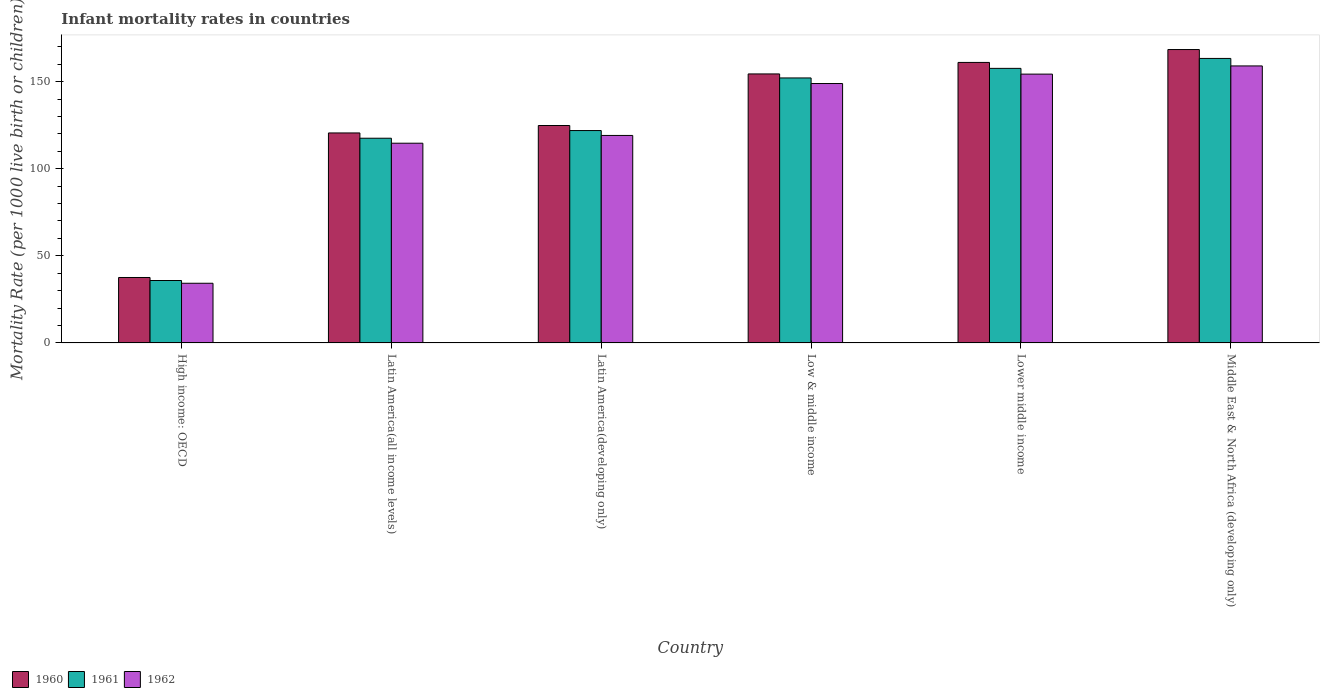How many different coloured bars are there?
Provide a succinct answer. 3. How many groups of bars are there?
Give a very brief answer. 6. How many bars are there on the 2nd tick from the left?
Your answer should be compact. 3. How many bars are there on the 6th tick from the right?
Keep it short and to the point. 3. What is the label of the 3rd group of bars from the left?
Give a very brief answer. Latin America(developing only). What is the infant mortality rate in 1961 in Low & middle income?
Provide a succinct answer. 152.1. Across all countries, what is the maximum infant mortality rate in 1962?
Give a very brief answer. 159. Across all countries, what is the minimum infant mortality rate in 1961?
Ensure brevity in your answer.  35.84. In which country was the infant mortality rate in 1962 maximum?
Provide a short and direct response. Middle East & North Africa (developing only). In which country was the infant mortality rate in 1961 minimum?
Provide a short and direct response. High income: OECD. What is the total infant mortality rate in 1961 in the graph?
Give a very brief answer. 748.24. What is the difference between the infant mortality rate in 1960 in Low & middle income and that in Lower middle income?
Your answer should be compact. -6.6. What is the difference between the infant mortality rate in 1960 in High income: OECD and the infant mortality rate in 1961 in Latin America(developing only)?
Make the answer very short. -84.33. What is the average infant mortality rate in 1960 per country?
Make the answer very short. 127.78. What is the difference between the infant mortality rate of/in 1960 and infant mortality rate of/in 1961 in Middle East & North Africa (developing only)?
Offer a terse response. 5.1. What is the ratio of the infant mortality rate in 1962 in Latin America(developing only) to that in Lower middle income?
Make the answer very short. 0.77. What is the difference between the highest and the second highest infant mortality rate in 1960?
Provide a succinct answer. 7.4. What is the difference between the highest and the lowest infant mortality rate in 1961?
Offer a terse response. 127.46. Is the sum of the infant mortality rate in 1961 in High income: OECD and Lower middle income greater than the maximum infant mortality rate in 1960 across all countries?
Make the answer very short. Yes. Is it the case that in every country, the sum of the infant mortality rate in 1961 and infant mortality rate in 1962 is greater than the infant mortality rate in 1960?
Your answer should be compact. Yes. How many bars are there?
Provide a succinct answer. 18. Are all the bars in the graph horizontal?
Your answer should be compact. No. How many countries are there in the graph?
Provide a short and direct response. 6. Where does the legend appear in the graph?
Make the answer very short. Bottom left. How many legend labels are there?
Keep it short and to the point. 3. What is the title of the graph?
Offer a terse response. Infant mortality rates in countries. What is the label or title of the Y-axis?
Offer a terse response. Mortality Rate (per 1000 live birth or children). What is the Mortality Rate (per 1000 live birth or children) of 1960 in High income: OECD?
Provide a short and direct response. 37.57. What is the Mortality Rate (per 1000 live birth or children) in 1961 in High income: OECD?
Offer a very short reply. 35.84. What is the Mortality Rate (per 1000 live birth or children) of 1962 in High income: OECD?
Provide a short and direct response. 34.26. What is the Mortality Rate (per 1000 live birth or children) in 1960 in Latin America(all income levels)?
Your response must be concise. 120.53. What is the Mortality Rate (per 1000 live birth or children) in 1961 in Latin America(all income levels)?
Give a very brief answer. 117.5. What is the Mortality Rate (per 1000 live birth or children) of 1962 in Latin America(all income levels)?
Your answer should be compact. 114.64. What is the Mortality Rate (per 1000 live birth or children) in 1960 in Latin America(developing only)?
Make the answer very short. 124.8. What is the Mortality Rate (per 1000 live birth or children) in 1961 in Latin America(developing only)?
Offer a terse response. 121.9. What is the Mortality Rate (per 1000 live birth or children) of 1962 in Latin America(developing only)?
Offer a terse response. 119.1. What is the Mortality Rate (per 1000 live birth or children) of 1960 in Low & middle income?
Provide a short and direct response. 154.4. What is the Mortality Rate (per 1000 live birth or children) of 1961 in Low & middle income?
Provide a succinct answer. 152.1. What is the Mortality Rate (per 1000 live birth or children) in 1962 in Low & middle income?
Your response must be concise. 148.9. What is the Mortality Rate (per 1000 live birth or children) of 1960 in Lower middle income?
Provide a succinct answer. 161. What is the Mortality Rate (per 1000 live birth or children) in 1961 in Lower middle income?
Your answer should be very brief. 157.6. What is the Mortality Rate (per 1000 live birth or children) of 1962 in Lower middle income?
Your answer should be very brief. 154.3. What is the Mortality Rate (per 1000 live birth or children) of 1960 in Middle East & North Africa (developing only)?
Give a very brief answer. 168.4. What is the Mortality Rate (per 1000 live birth or children) of 1961 in Middle East & North Africa (developing only)?
Provide a succinct answer. 163.3. What is the Mortality Rate (per 1000 live birth or children) in 1962 in Middle East & North Africa (developing only)?
Offer a very short reply. 159. Across all countries, what is the maximum Mortality Rate (per 1000 live birth or children) of 1960?
Provide a succinct answer. 168.4. Across all countries, what is the maximum Mortality Rate (per 1000 live birth or children) in 1961?
Offer a terse response. 163.3. Across all countries, what is the maximum Mortality Rate (per 1000 live birth or children) of 1962?
Offer a terse response. 159. Across all countries, what is the minimum Mortality Rate (per 1000 live birth or children) in 1960?
Your answer should be very brief. 37.57. Across all countries, what is the minimum Mortality Rate (per 1000 live birth or children) in 1961?
Provide a short and direct response. 35.84. Across all countries, what is the minimum Mortality Rate (per 1000 live birth or children) of 1962?
Give a very brief answer. 34.26. What is the total Mortality Rate (per 1000 live birth or children) of 1960 in the graph?
Make the answer very short. 766.7. What is the total Mortality Rate (per 1000 live birth or children) of 1961 in the graph?
Offer a terse response. 748.24. What is the total Mortality Rate (per 1000 live birth or children) in 1962 in the graph?
Your answer should be very brief. 730.19. What is the difference between the Mortality Rate (per 1000 live birth or children) of 1960 in High income: OECD and that in Latin America(all income levels)?
Make the answer very short. -82.96. What is the difference between the Mortality Rate (per 1000 live birth or children) of 1961 in High income: OECD and that in Latin America(all income levels)?
Provide a short and direct response. -81.67. What is the difference between the Mortality Rate (per 1000 live birth or children) of 1962 in High income: OECD and that in Latin America(all income levels)?
Give a very brief answer. -80.38. What is the difference between the Mortality Rate (per 1000 live birth or children) of 1960 in High income: OECD and that in Latin America(developing only)?
Your answer should be very brief. -87.23. What is the difference between the Mortality Rate (per 1000 live birth or children) in 1961 in High income: OECD and that in Latin America(developing only)?
Give a very brief answer. -86.06. What is the difference between the Mortality Rate (per 1000 live birth or children) in 1962 in High income: OECD and that in Latin America(developing only)?
Provide a succinct answer. -84.84. What is the difference between the Mortality Rate (per 1000 live birth or children) of 1960 in High income: OECD and that in Low & middle income?
Provide a short and direct response. -116.83. What is the difference between the Mortality Rate (per 1000 live birth or children) of 1961 in High income: OECD and that in Low & middle income?
Make the answer very short. -116.26. What is the difference between the Mortality Rate (per 1000 live birth or children) of 1962 in High income: OECD and that in Low & middle income?
Offer a terse response. -114.64. What is the difference between the Mortality Rate (per 1000 live birth or children) of 1960 in High income: OECD and that in Lower middle income?
Give a very brief answer. -123.43. What is the difference between the Mortality Rate (per 1000 live birth or children) of 1961 in High income: OECD and that in Lower middle income?
Provide a short and direct response. -121.76. What is the difference between the Mortality Rate (per 1000 live birth or children) in 1962 in High income: OECD and that in Lower middle income?
Your answer should be very brief. -120.04. What is the difference between the Mortality Rate (per 1000 live birth or children) of 1960 in High income: OECD and that in Middle East & North Africa (developing only)?
Make the answer very short. -130.83. What is the difference between the Mortality Rate (per 1000 live birth or children) of 1961 in High income: OECD and that in Middle East & North Africa (developing only)?
Offer a terse response. -127.46. What is the difference between the Mortality Rate (per 1000 live birth or children) of 1962 in High income: OECD and that in Middle East & North Africa (developing only)?
Offer a terse response. -124.74. What is the difference between the Mortality Rate (per 1000 live birth or children) of 1960 in Latin America(all income levels) and that in Latin America(developing only)?
Offer a terse response. -4.27. What is the difference between the Mortality Rate (per 1000 live birth or children) in 1961 in Latin America(all income levels) and that in Latin America(developing only)?
Provide a succinct answer. -4.4. What is the difference between the Mortality Rate (per 1000 live birth or children) of 1962 in Latin America(all income levels) and that in Latin America(developing only)?
Provide a succinct answer. -4.46. What is the difference between the Mortality Rate (per 1000 live birth or children) of 1960 in Latin America(all income levels) and that in Low & middle income?
Give a very brief answer. -33.87. What is the difference between the Mortality Rate (per 1000 live birth or children) of 1961 in Latin America(all income levels) and that in Low & middle income?
Provide a short and direct response. -34.6. What is the difference between the Mortality Rate (per 1000 live birth or children) in 1962 in Latin America(all income levels) and that in Low & middle income?
Offer a very short reply. -34.26. What is the difference between the Mortality Rate (per 1000 live birth or children) in 1960 in Latin America(all income levels) and that in Lower middle income?
Ensure brevity in your answer.  -40.47. What is the difference between the Mortality Rate (per 1000 live birth or children) of 1961 in Latin America(all income levels) and that in Lower middle income?
Keep it short and to the point. -40.1. What is the difference between the Mortality Rate (per 1000 live birth or children) of 1962 in Latin America(all income levels) and that in Lower middle income?
Offer a terse response. -39.66. What is the difference between the Mortality Rate (per 1000 live birth or children) in 1960 in Latin America(all income levels) and that in Middle East & North Africa (developing only)?
Provide a short and direct response. -47.87. What is the difference between the Mortality Rate (per 1000 live birth or children) in 1961 in Latin America(all income levels) and that in Middle East & North Africa (developing only)?
Make the answer very short. -45.8. What is the difference between the Mortality Rate (per 1000 live birth or children) of 1962 in Latin America(all income levels) and that in Middle East & North Africa (developing only)?
Ensure brevity in your answer.  -44.36. What is the difference between the Mortality Rate (per 1000 live birth or children) of 1960 in Latin America(developing only) and that in Low & middle income?
Offer a very short reply. -29.6. What is the difference between the Mortality Rate (per 1000 live birth or children) of 1961 in Latin America(developing only) and that in Low & middle income?
Offer a very short reply. -30.2. What is the difference between the Mortality Rate (per 1000 live birth or children) in 1962 in Latin America(developing only) and that in Low & middle income?
Make the answer very short. -29.8. What is the difference between the Mortality Rate (per 1000 live birth or children) of 1960 in Latin America(developing only) and that in Lower middle income?
Make the answer very short. -36.2. What is the difference between the Mortality Rate (per 1000 live birth or children) of 1961 in Latin America(developing only) and that in Lower middle income?
Provide a short and direct response. -35.7. What is the difference between the Mortality Rate (per 1000 live birth or children) in 1962 in Latin America(developing only) and that in Lower middle income?
Your answer should be compact. -35.2. What is the difference between the Mortality Rate (per 1000 live birth or children) of 1960 in Latin America(developing only) and that in Middle East & North Africa (developing only)?
Your answer should be compact. -43.6. What is the difference between the Mortality Rate (per 1000 live birth or children) of 1961 in Latin America(developing only) and that in Middle East & North Africa (developing only)?
Make the answer very short. -41.4. What is the difference between the Mortality Rate (per 1000 live birth or children) of 1962 in Latin America(developing only) and that in Middle East & North Africa (developing only)?
Ensure brevity in your answer.  -39.9. What is the difference between the Mortality Rate (per 1000 live birth or children) of 1961 in Low & middle income and that in Lower middle income?
Keep it short and to the point. -5.5. What is the difference between the Mortality Rate (per 1000 live birth or children) in 1960 in Lower middle income and that in Middle East & North Africa (developing only)?
Your answer should be very brief. -7.4. What is the difference between the Mortality Rate (per 1000 live birth or children) of 1961 in Lower middle income and that in Middle East & North Africa (developing only)?
Provide a short and direct response. -5.7. What is the difference between the Mortality Rate (per 1000 live birth or children) in 1962 in Lower middle income and that in Middle East & North Africa (developing only)?
Keep it short and to the point. -4.7. What is the difference between the Mortality Rate (per 1000 live birth or children) in 1960 in High income: OECD and the Mortality Rate (per 1000 live birth or children) in 1961 in Latin America(all income levels)?
Provide a succinct answer. -79.93. What is the difference between the Mortality Rate (per 1000 live birth or children) of 1960 in High income: OECD and the Mortality Rate (per 1000 live birth or children) of 1962 in Latin America(all income levels)?
Your answer should be very brief. -77.07. What is the difference between the Mortality Rate (per 1000 live birth or children) in 1961 in High income: OECD and the Mortality Rate (per 1000 live birth or children) in 1962 in Latin America(all income levels)?
Your answer should be compact. -78.8. What is the difference between the Mortality Rate (per 1000 live birth or children) in 1960 in High income: OECD and the Mortality Rate (per 1000 live birth or children) in 1961 in Latin America(developing only)?
Offer a very short reply. -84.33. What is the difference between the Mortality Rate (per 1000 live birth or children) in 1960 in High income: OECD and the Mortality Rate (per 1000 live birth or children) in 1962 in Latin America(developing only)?
Provide a succinct answer. -81.53. What is the difference between the Mortality Rate (per 1000 live birth or children) in 1961 in High income: OECD and the Mortality Rate (per 1000 live birth or children) in 1962 in Latin America(developing only)?
Your answer should be compact. -83.26. What is the difference between the Mortality Rate (per 1000 live birth or children) of 1960 in High income: OECD and the Mortality Rate (per 1000 live birth or children) of 1961 in Low & middle income?
Make the answer very short. -114.53. What is the difference between the Mortality Rate (per 1000 live birth or children) in 1960 in High income: OECD and the Mortality Rate (per 1000 live birth or children) in 1962 in Low & middle income?
Make the answer very short. -111.33. What is the difference between the Mortality Rate (per 1000 live birth or children) in 1961 in High income: OECD and the Mortality Rate (per 1000 live birth or children) in 1962 in Low & middle income?
Your response must be concise. -113.06. What is the difference between the Mortality Rate (per 1000 live birth or children) in 1960 in High income: OECD and the Mortality Rate (per 1000 live birth or children) in 1961 in Lower middle income?
Offer a terse response. -120.03. What is the difference between the Mortality Rate (per 1000 live birth or children) in 1960 in High income: OECD and the Mortality Rate (per 1000 live birth or children) in 1962 in Lower middle income?
Make the answer very short. -116.73. What is the difference between the Mortality Rate (per 1000 live birth or children) in 1961 in High income: OECD and the Mortality Rate (per 1000 live birth or children) in 1962 in Lower middle income?
Offer a terse response. -118.46. What is the difference between the Mortality Rate (per 1000 live birth or children) of 1960 in High income: OECD and the Mortality Rate (per 1000 live birth or children) of 1961 in Middle East & North Africa (developing only)?
Provide a succinct answer. -125.73. What is the difference between the Mortality Rate (per 1000 live birth or children) of 1960 in High income: OECD and the Mortality Rate (per 1000 live birth or children) of 1962 in Middle East & North Africa (developing only)?
Provide a succinct answer. -121.43. What is the difference between the Mortality Rate (per 1000 live birth or children) in 1961 in High income: OECD and the Mortality Rate (per 1000 live birth or children) in 1962 in Middle East & North Africa (developing only)?
Provide a short and direct response. -123.16. What is the difference between the Mortality Rate (per 1000 live birth or children) in 1960 in Latin America(all income levels) and the Mortality Rate (per 1000 live birth or children) in 1961 in Latin America(developing only)?
Provide a short and direct response. -1.37. What is the difference between the Mortality Rate (per 1000 live birth or children) of 1960 in Latin America(all income levels) and the Mortality Rate (per 1000 live birth or children) of 1962 in Latin America(developing only)?
Your answer should be very brief. 1.43. What is the difference between the Mortality Rate (per 1000 live birth or children) of 1961 in Latin America(all income levels) and the Mortality Rate (per 1000 live birth or children) of 1962 in Latin America(developing only)?
Your answer should be very brief. -1.6. What is the difference between the Mortality Rate (per 1000 live birth or children) of 1960 in Latin America(all income levels) and the Mortality Rate (per 1000 live birth or children) of 1961 in Low & middle income?
Provide a succinct answer. -31.57. What is the difference between the Mortality Rate (per 1000 live birth or children) of 1960 in Latin America(all income levels) and the Mortality Rate (per 1000 live birth or children) of 1962 in Low & middle income?
Your answer should be very brief. -28.37. What is the difference between the Mortality Rate (per 1000 live birth or children) in 1961 in Latin America(all income levels) and the Mortality Rate (per 1000 live birth or children) in 1962 in Low & middle income?
Your answer should be compact. -31.4. What is the difference between the Mortality Rate (per 1000 live birth or children) in 1960 in Latin America(all income levels) and the Mortality Rate (per 1000 live birth or children) in 1961 in Lower middle income?
Your answer should be compact. -37.07. What is the difference between the Mortality Rate (per 1000 live birth or children) of 1960 in Latin America(all income levels) and the Mortality Rate (per 1000 live birth or children) of 1962 in Lower middle income?
Provide a short and direct response. -33.77. What is the difference between the Mortality Rate (per 1000 live birth or children) of 1961 in Latin America(all income levels) and the Mortality Rate (per 1000 live birth or children) of 1962 in Lower middle income?
Provide a succinct answer. -36.8. What is the difference between the Mortality Rate (per 1000 live birth or children) of 1960 in Latin America(all income levels) and the Mortality Rate (per 1000 live birth or children) of 1961 in Middle East & North Africa (developing only)?
Your answer should be compact. -42.77. What is the difference between the Mortality Rate (per 1000 live birth or children) in 1960 in Latin America(all income levels) and the Mortality Rate (per 1000 live birth or children) in 1962 in Middle East & North Africa (developing only)?
Provide a succinct answer. -38.47. What is the difference between the Mortality Rate (per 1000 live birth or children) in 1961 in Latin America(all income levels) and the Mortality Rate (per 1000 live birth or children) in 1962 in Middle East & North Africa (developing only)?
Offer a terse response. -41.5. What is the difference between the Mortality Rate (per 1000 live birth or children) in 1960 in Latin America(developing only) and the Mortality Rate (per 1000 live birth or children) in 1961 in Low & middle income?
Ensure brevity in your answer.  -27.3. What is the difference between the Mortality Rate (per 1000 live birth or children) of 1960 in Latin America(developing only) and the Mortality Rate (per 1000 live birth or children) of 1962 in Low & middle income?
Provide a short and direct response. -24.1. What is the difference between the Mortality Rate (per 1000 live birth or children) of 1960 in Latin America(developing only) and the Mortality Rate (per 1000 live birth or children) of 1961 in Lower middle income?
Your response must be concise. -32.8. What is the difference between the Mortality Rate (per 1000 live birth or children) in 1960 in Latin America(developing only) and the Mortality Rate (per 1000 live birth or children) in 1962 in Lower middle income?
Provide a succinct answer. -29.5. What is the difference between the Mortality Rate (per 1000 live birth or children) of 1961 in Latin America(developing only) and the Mortality Rate (per 1000 live birth or children) of 1962 in Lower middle income?
Give a very brief answer. -32.4. What is the difference between the Mortality Rate (per 1000 live birth or children) in 1960 in Latin America(developing only) and the Mortality Rate (per 1000 live birth or children) in 1961 in Middle East & North Africa (developing only)?
Make the answer very short. -38.5. What is the difference between the Mortality Rate (per 1000 live birth or children) of 1960 in Latin America(developing only) and the Mortality Rate (per 1000 live birth or children) of 1962 in Middle East & North Africa (developing only)?
Your answer should be very brief. -34.2. What is the difference between the Mortality Rate (per 1000 live birth or children) in 1961 in Latin America(developing only) and the Mortality Rate (per 1000 live birth or children) in 1962 in Middle East & North Africa (developing only)?
Provide a short and direct response. -37.1. What is the difference between the Mortality Rate (per 1000 live birth or children) in 1960 in Low & middle income and the Mortality Rate (per 1000 live birth or children) in 1961 in Lower middle income?
Offer a very short reply. -3.2. What is the average Mortality Rate (per 1000 live birth or children) in 1960 per country?
Your answer should be compact. 127.78. What is the average Mortality Rate (per 1000 live birth or children) in 1961 per country?
Provide a short and direct response. 124.71. What is the average Mortality Rate (per 1000 live birth or children) in 1962 per country?
Offer a terse response. 121.7. What is the difference between the Mortality Rate (per 1000 live birth or children) of 1960 and Mortality Rate (per 1000 live birth or children) of 1961 in High income: OECD?
Offer a terse response. 1.73. What is the difference between the Mortality Rate (per 1000 live birth or children) in 1960 and Mortality Rate (per 1000 live birth or children) in 1962 in High income: OECD?
Provide a succinct answer. 3.31. What is the difference between the Mortality Rate (per 1000 live birth or children) of 1961 and Mortality Rate (per 1000 live birth or children) of 1962 in High income: OECD?
Offer a terse response. 1.58. What is the difference between the Mortality Rate (per 1000 live birth or children) of 1960 and Mortality Rate (per 1000 live birth or children) of 1961 in Latin America(all income levels)?
Your answer should be compact. 3.03. What is the difference between the Mortality Rate (per 1000 live birth or children) of 1960 and Mortality Rate (per 1000 live birth or children) of 1962 in Latin America(all income levels)?
Offer a very short reply. 5.9. What is the difference between the Mortality Rate (per 1000 live birth or children) of 1961 and Mortality Rate (per 1000 live birth or children) of 1962 in Latin America(all income levels)?
Offer a terse response. 2.87. What is the difference between the Mortality Rate (per 1000 live birth or children) in 1960 and Mortality Rate (per 1000 live birth or children) in 1962 in Low & middle income?
Provide a succinct answer. 5.5. What is the difference between the Mortality Rate (per 1000 live birth or children) of 1961 and Mortality Rate (per 1000 live birth or children) of 1962 in Low & middle income?
Your response must be concise. 3.2. What is the difference between the Mortality Rate (per 1000 live birth or children) in 1960 and Mortality Rate (per 1000 live birth or children) in 1962 in Lower middle income?
Provide a short and direct response. 6.7. What is the difference between the Mortality Rate (per 1000 live birth or children) of 1961 and Mortality Rate (per 1000 live birth or children) of 1962 in Lower middle income?
Provide a short and direct response. 3.3. What is the difference between the Mortality Rate (per 1000 live birth or children) in 1960 and Mortality Rate (per 1000 live birth or children) in 1961 in Middle East & North Africa (developing only)?
Keep it short and to the point. 5.1. What is the difference between the Mortality Rate (per 1000 live birth or children) in 1961 and Mortality Rate (per 1000 live birth or children) in 1962 in Middle East & North Africa (developing only)?
Your answer should be very brief. 4.3. What is the ratio of the Mortality Rate (per 1000 live birth or children) in 1960 in High income: OECD to that in Latin America(all income levels)?
Give a very brief answer. 0.31. What is the ratio of the Mortality Rate (per 1000 live birth or children) of 1961 in High income: OECD to that in Latin America(all income levels)?
Offer a terse response. 0.3. What is the ratio of the Mortality Rate (per 1000 live birth or children) in 1962 in High income: OECD to that in Latin America(all income levels)?
Keep it short and to the point. 0.3. What is the ratio of the Mortality Rate (per 1000 live birth or children) of 1960 in High income: OECD to that in Latin America(developing only)?
Provide a succinct answer. 0.3. What is the ratio of the Mortality Rate (per 1000 live birth or children) in 1961 in High income: OECD to that in Latin America(developing only)?
Keep it short and to the point. 0.29. What is the ratio of the Mortality Rate (per 1000 live birth or children) in 1962 in High income: OECD to that in Latin America(developing only)?
Make the answer very short. 0.29. What is the ratio of the Mortality Rate (per 1000 live birth or children) in 1960 in High income: OECD to that in Low & middle income?
Your answer should be compact. 0.24. What is the ratio of the Mortality Rate (per 1000 live birth or children) in 1961 in High income: OECD to that in Low & middle income?
Offer a terse response. 0.24. What is the ratio of the Mortality Rate (per 1000 live birth or children) in 1962 in High income: OECD to that in Low & middle income?
Offer a terse response. 0.23. What is the ratio of the Mortality Rate (per 1000 live birth or children) in 1960 in High income: OECD to that in Lower middle income?
Offer a very short reply. 0.23. What is the ratio of the Mortality Rate (per 1000 live birth or children) in 1961 in High income: OECD to that in Lower middle income?
Make the answer very short. 0.23. What is the ratio of the Mortality Rate (per 1000 live birth or children) in 1962 in High income: OECD to that in Lower middle income?
Ensure brevity in your answer.  0.22. What is the ratio of the Mortality Rate (per 1000 live birth or children) of 1960 in High income: OECD to that in Middle East & North Africa (developing only)?
Offer a terse response. 0.22. What is the ratio of the Mortality Rate (per 1000 live birth or children) in 1961 in High income: OECD to that in Middle East & North Africa (developing only)?
Offer a terse response. 0.22. What is the ratio of the Mortality Rate (per 1000 live birth or children) in 1962 in High income: OECD to that in Middle East & North Africa (developing only)?
Give a very brief answer. 0.22. What is the ratio of the Mortality Rate (per 1000 live birth or children) of 1960 in Latin America(all income levels) to that in Latin America(developing only)?
Offer a terse response. 0.97. What is the ratio of the Mortality Rate (per 1000 live birth or children) in 1961 in Latin America(all income levels) to that in Latin America(developing only)?
Keep it short and to the point. 0.96. What is the ratio of the Mortality Rate (per 1000 live birth or children) in 1962 in Latin America(all income levels) to that in Latin America(developing only)?
Your answer should be very brief. 0.96. What is the ratio of the Mortality Rate (per 1000 live birth or children) in 1960 in Latin America(all income levels) to that in Low & middle income?
Your answer should be very brief. 0.78. What is the ratio of the Mortality Rate (per 1000 live birth or children) of 1961 in Latin America(all income levels) to that in Low & middle income?
Offer a very short reply. 0.77. What is the ratio of the Mortality Rate (per 1000 live birth or children) in 1962 in Latin America(all income levels) to that in Low & middle income?
Provide a short and direct response. 0.77. What is the ratio of the Mortality Rate (per 1000 live birth or children) in 1960 in Latin America(all income levels) to that in Lower middle income?
Keep it short and to the point. 0.75. What is the ratio of the Mortality Rate (per 1000 live birth or children) in 1961 in Latin America(all income levels) to that in Lower middle income?
Give a very brief answer. 0.75. What is the ratio of the Mortality Rate (per 1000 live birth or children) of 1962 in Latin America(all income levels) to that in Lower middle income?
Your response must be concise. 0.74. What is the ratio of the Mortality Rate (per 1000 live birth or children) of 1960 in Latin America(all income levels) to that in Middle East & North Africa (developing only)?
Your answer should be very brief. 0.72. What is the ratio of the Mortality Rate (per 1000 live birth or children) of 1961 in Latin America(all income levels) to that in Middle East & North Africa (developing only)?
Ensure brevity in your answer.  0.72. What is the ratio of the Mortality Rate (per 1000 live birth or children) of 1962 in Latin America(all income levels) to that in Middle East & North Africa (developing only)?
Your response must be concise. 0.72. What is the ratio of the Mortality Rate (per 1000 live birth or children) of 1960 in Latin America(developing only) to that in Low & middle income?
Your answer should be very brief. 0.81. What is the ratio of the Mortality Rate (per 1000 live birth or children) of 1961 in Latin America(developing only) to that in Low & middle income?
Keep it short and to the point. 0.8. What is the ratio of the Mortality Rate (per 1000 live birth or children) in 1962 in Latin America(developing only) to that in Low & middle income?
Give a very brief answer. 0.8. What is the ratio of the Mortality Rate (per 1000 live birth or children) in 1960 in Latin America(developing only) to that in Lower middle income?
Offer a terse response. 0.78. What is the ratio of the Mortality Rate (per 1000 live birth or children) in 1961 in Latin America(developing only) to that in Lower middle income?
Your answer should be compact. 0.77. What is the ratio of the Mortality Rate (per 1000 live birth or children) of 1962 in Latin America(developing only) to that in Lower middle income?
Provide a succinct answer. 0.77. What is the ratio of the Mortality Rate (per 1000 live birth or children) of 1960 in Latin America(developing only) to that in Middle East & North Africa (developing only)?
Provide a succinct answer. 0.74. What is the ratio of the Mortality Rate (per 1000 live birth or children) of 1961 in Latin America(developing only) to that in Middle East & North Africa (developing only)?
Your answer should be very brief. 0.75. What is the ratio of the Mortality Rate (per 1000 live birth or children) of 1962 in Latin America(developing only) to that in Middle East & North Africa (developing only)?
Make the answer very short. 0.75. What is the ratio of the Mortality Rate (per 1000 live birth or children) in 1960 in Low & middle income to that in Lower middle income?
Your response must be concise. 0.96. What is the ratio of the Mortality Rate (per 1000 live birth or children) in 1961 in Low & middle income to that in Lower middle income?
Keep it short and to the point. 0.97. What is the ratio of the Mortality Rate (per 1000 live birth or children) in 1960 in Low & middle income to that in Middle East & North Africa (developing only)?
Offer a very short reply. 0.92. What is the ratio of the Mortality Rate (per 1000 live birth or children) of 1961 in Low & middle income to that in Middle East & North Africa (developing only)?
Make the answer very short. 0.93. What is the ratio of the Mortality Rate (per 1000 live birth or children) in 1962 in Low & middle income to that in Middle East & North Africa (developing only)?
Offer a very short reply. 0.94. What is the ratio of the Mortality Rate (per 1000 live birth or children) of 1960 in Lower middle income to that in Middle East & North Africa (developing only)?
Offer a terse response. 0.96. What is the ratio of the Mortality Rate (per 1000 live birth or children) of 1961 in Lower middle income to that in Middle East & North Africa (developing only)?
Give a very brief answer. 0.97. What is the ratio of the Mortality Rate (per 1000 live birth or children) of 1962 in Lower middle income to that in Middle East & North Africa (developing only)?
Make the answer very short. 0.97. What is the difference between the highest and the second highest Mortality Rate (per 1000 live birth or children) in 1960?
Offer a very short reply. 7.4. What is the difference between the highest and the second highest Mortality Rate (per 1000 live birth or children) of 1962?
Keep it short and to the point. 4.7. What is the difference between the highest and the lowest Mortality Rate (per 1000 live birth or children) in 1960?
Make the answer very short. 130.83. What is the difference between the highest and the lowest Mortality Rate (per 1000 live birth or children) in 1961?
Provide a succinct answer. 127.46. What is the difference between the highest and the lowest Mortality Rate (per 1000 live birth or children) of 1962?
Keep it short and to the point. 124.74. 